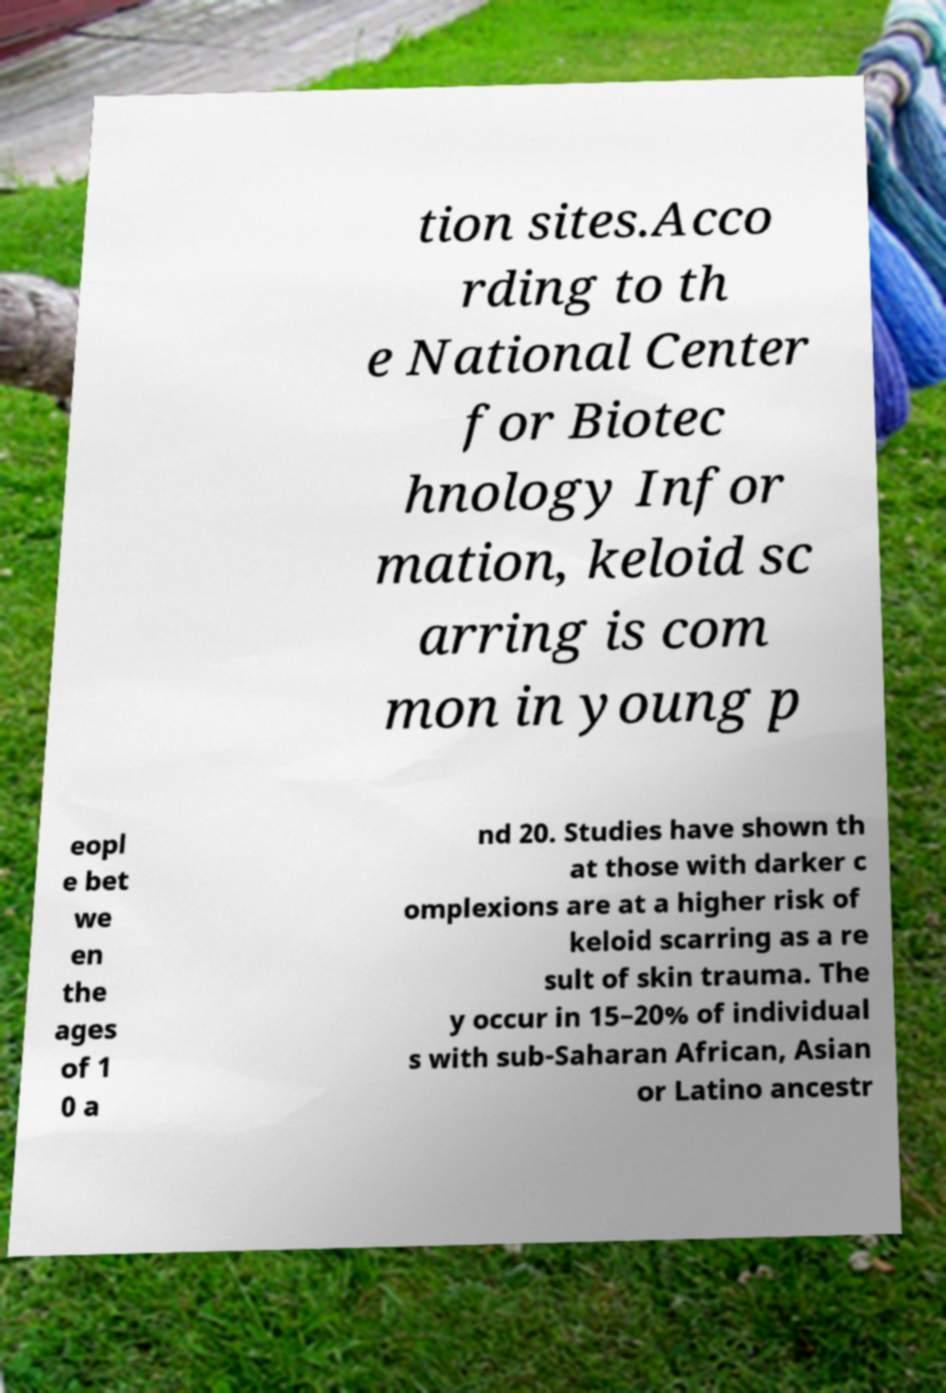Please read and relay the text visible in this image. What does it say? tion sites.Acco rding to th e National Center for Biotec hnology Infor mation, keloid sc arring is com mon in young p eopl e bet we en the ages of 1 0 a nd 20. Studies have shown th at those with darker c omplexions are at a higher risk of keloid scarring as a re sult of skin trauma. The y occur in 15–20% of individual s with sub-Saharan African, Asian or Latino ancestr 